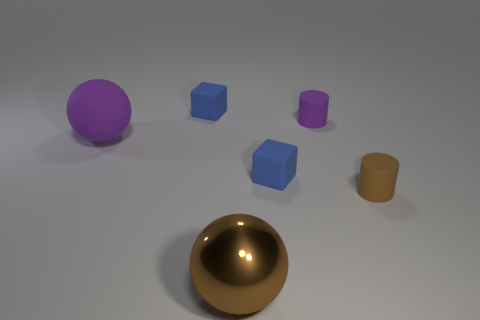There is a brown cylinder that is made of the same material as the purple cylinder; what is its size?
Provide a short and direct response. Small. There is a blue rubber block that is in front of the tiny purple matte cylinder; does it have the same size as the shiny ball that is in front of the big matte sphere?
Ensure brevity in your answer.  No. How many things are either objects behind the small brown matte thing or purple matte cylinders?
Provide a succinct answer. 4. Is the number of brown things less than the number of rubber objects?
Your response must be concise. Yes. There is a blue object left of the blue thing that is in front of the cube behind the small purple thing; what is its shape?
Your answer should be compact. Cube. There is a matte thing that is the same color as the metal ball; what is its shape?
Offer a terse response. Cylinder. Is there a gray cylinder?
Your answer should be very brief. No. Do the brown rubber object and the ball on the left side of the shiny sphere have the same size?
Provide a succinct answer. No. There is a tiny rubber thing that is on the left side of the large brown object; is there a large matte object behind it?
Your response must be concise. No. The sphere in front of the matte object that is on the right side of the small matte cylinder behind the large purple thing is what color?
Provide a succinct answer. Brown. 